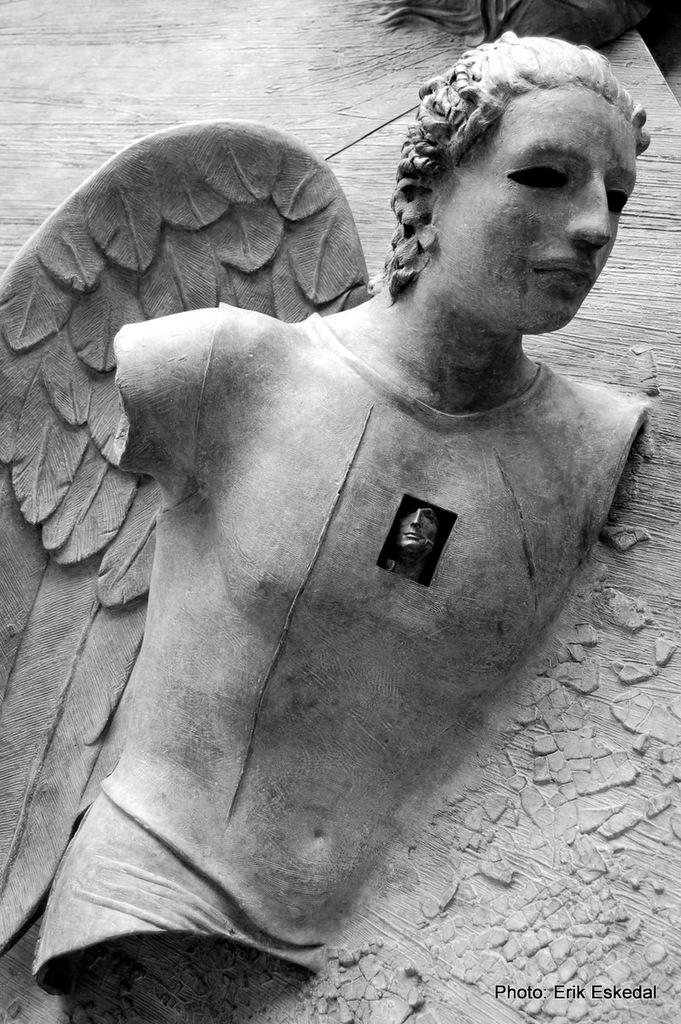What is the main subject of the image? There is a sculpture in the image. What is the color scheme of the image? The image is black and white in color. Is there any additional information or markings in the image? Yes, there is a watermark in the bottom right corner of the image. What is the plot of the book depicted in the image? There is no book present in the image, so there is no plot to discuss. 